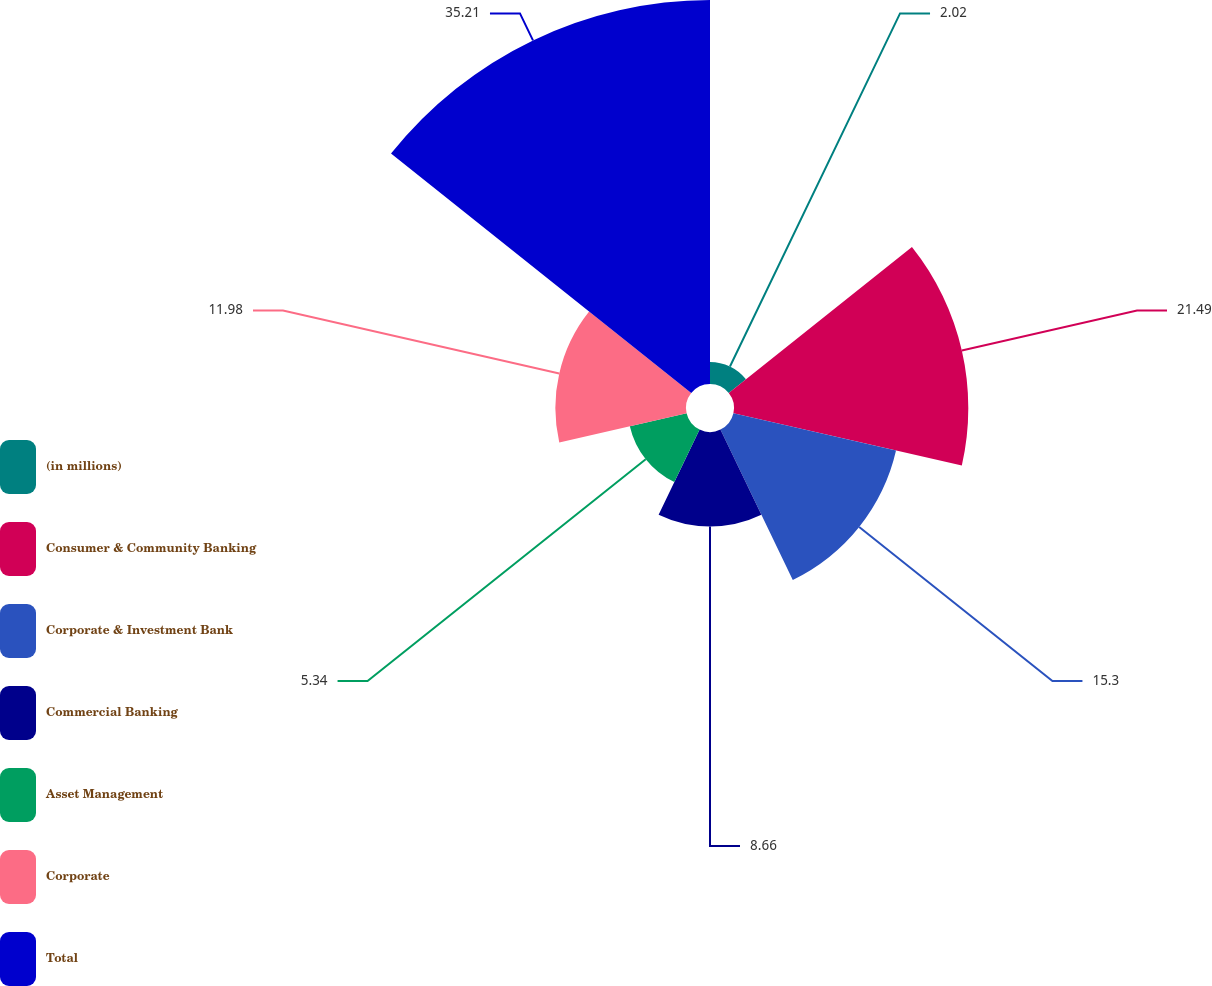Convert chart to OTSL. <chart><loc_0><loc_0><loc_500><loc_500><pie_chart><fcel>(in millions)<fcel>Consumer & Community Banking<fcel>Corporate & Investment Bank<fcel>Commercial Banking<fcel>Asset Management<fcel>Corporate<fcel>Total<nl><fcel>2.02%<fcel>21.49%<fcel>15.3%<fcel>8.66%<fcel>5.34%<fcel>11.98%<fcel>35.22%<nl></chart> 